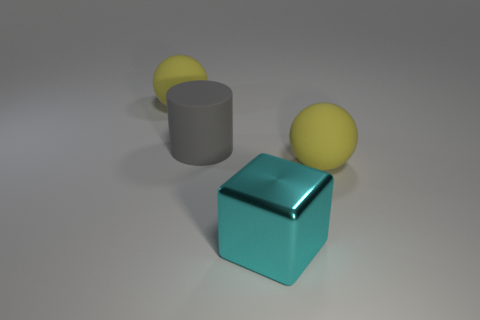Add 2 gray cylinders. How many objects exist? 6 Subtract all blocks. How many objects are left? 3 Subtract all red metal cylinders. Subtract all large balls. How many objects are left? 2 Add 1 large gray cylinders. How many large gray cylinders are left? 2 Add 4 large green things. How many large green things exist? 4 Subtract 0 blue cubes. How many objects are left? 4 